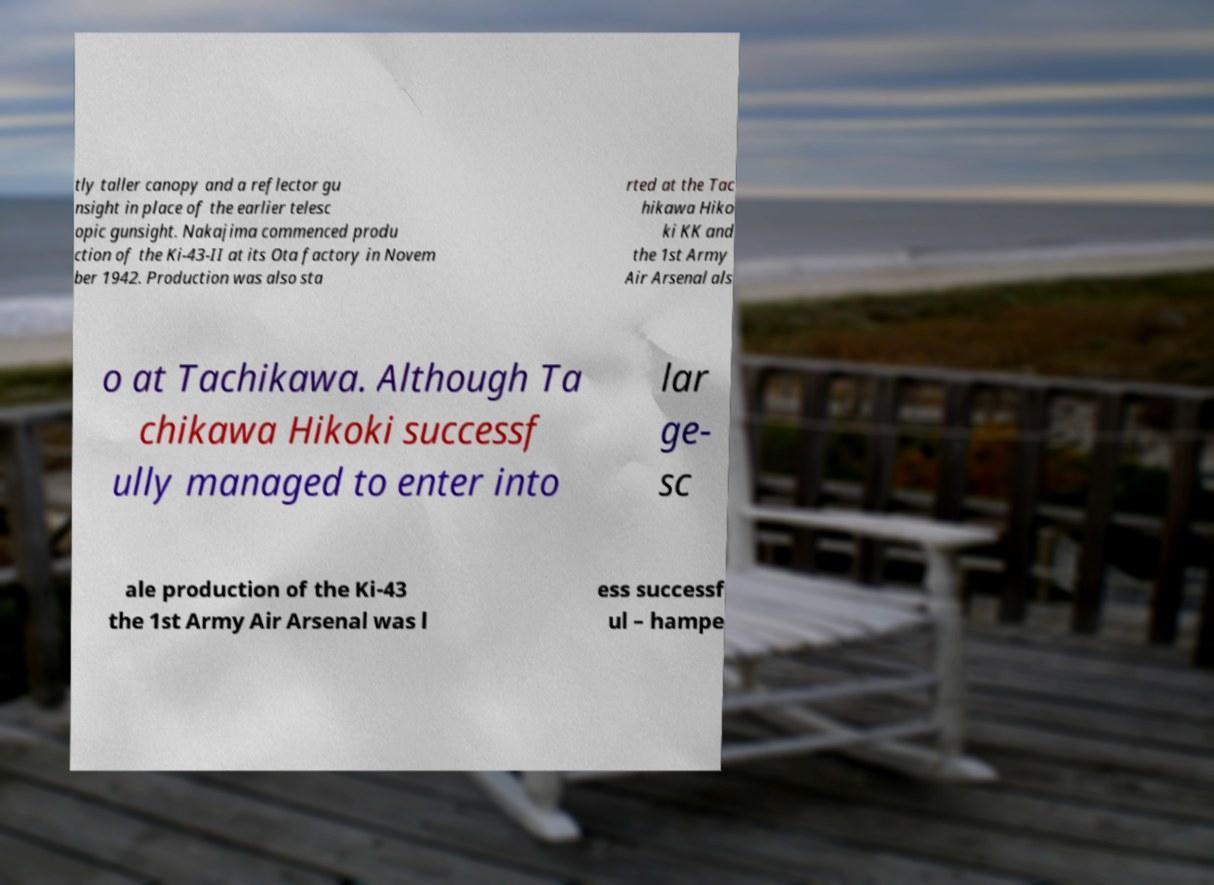Please identify and transcribe the text found in this image. tly taller canopy and a reflector gu nsight in place of the earlier telesc opic gunsight. Nakajima commenced produ ction of the Ki-43-II at its Ota factory in Novem ber 1942. Production was also sta rted at the Tac hikawa Hiko ki KK and the 1st Army Air Arsenal als o at Tachikawa. Although Ta chikawa Hikoki successf ully managed to enter into lar ge- sc ale production of the Ki-43 the 1st Army Air Arsenal was l ess successf ul – hampe 